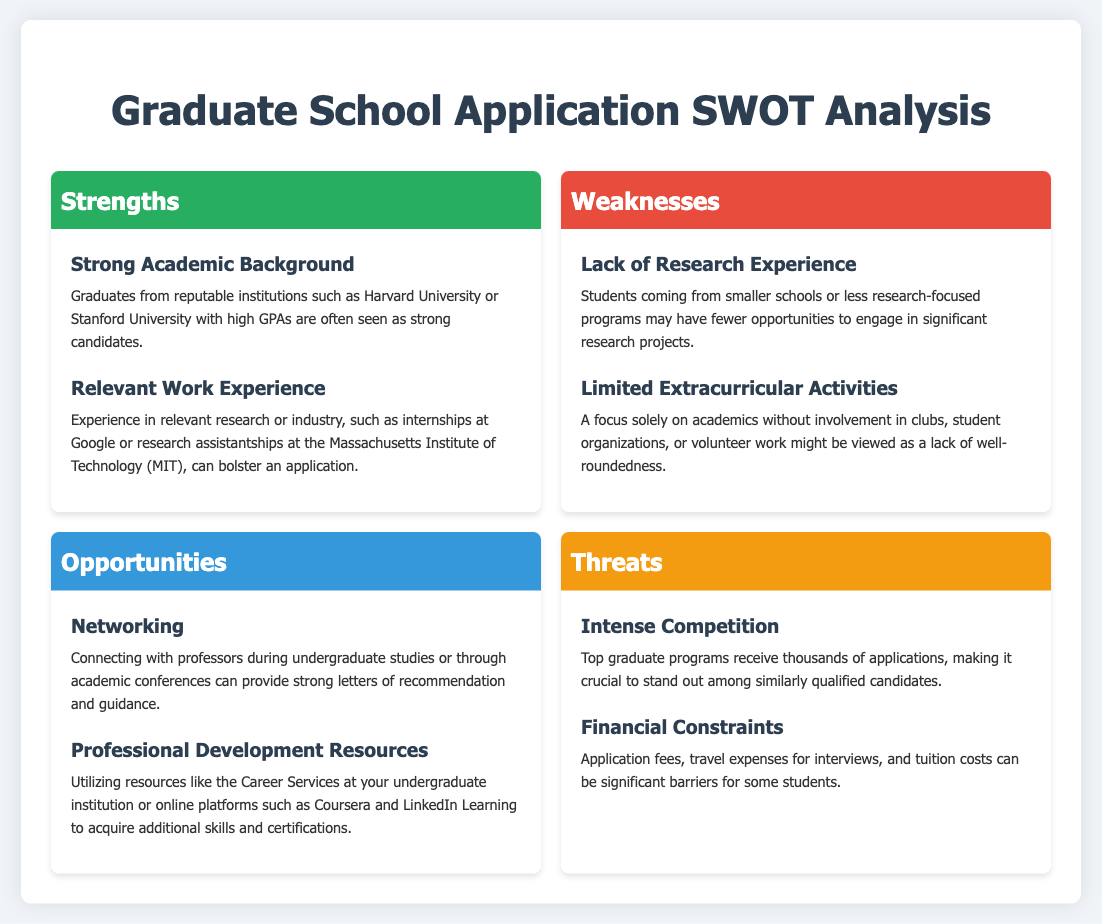What are the strengths listed in the document? The strengths are categorized sections in the SWOT analysis and contain specific points, including "Strong Academic Background" and "Relevant Work Experience."
Answer: Strong Academic Background, Relevant Work Experience How many weaknesses are mentioned? The weaknesses section includes two specific points that are outlined in the document.
Answer: 2 What type of opportunities can help in developing a strong application package? The opportunities section identifies specific aids such as networking and professional development resources that can enhance an application.
Answer: Networking, Professional Development Resources What is one weakness related to extracurricular activities? The weaknesses section indicates that limited involvement in extracurricular activities may be viewed negatively in applications.
Answer: Limited Extracurricular Activities What is one threat that applicants face regarding applications? The threats section explains that intense competition is a significant concern for applicants to top graduate programs.
Answer: Intense Competition 